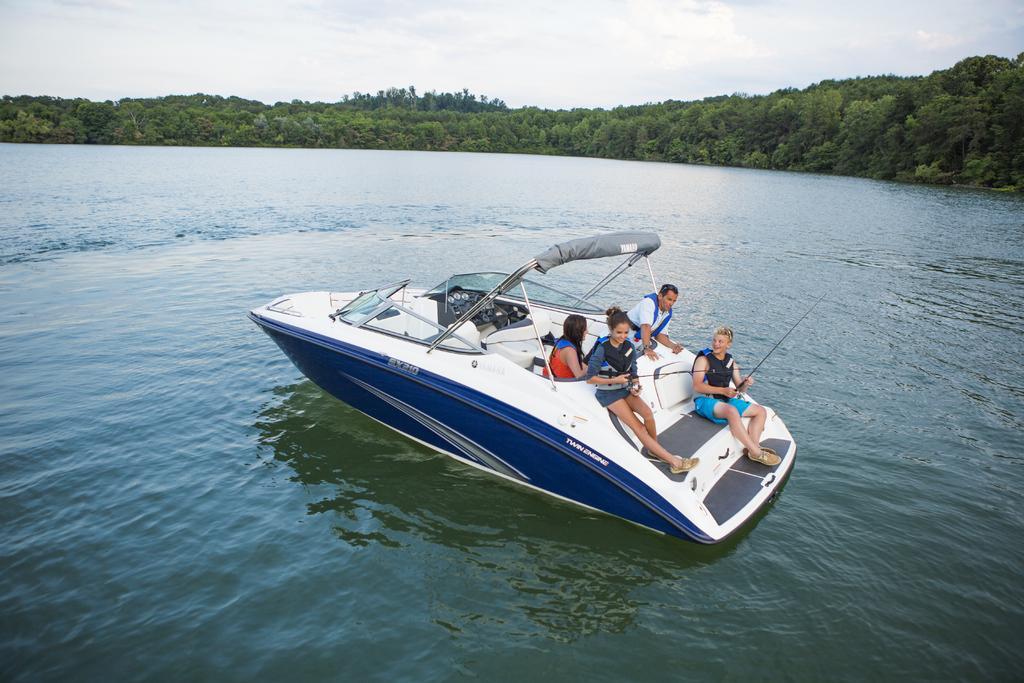Can you describe this image briefly? In the foreground of this picture, there is a boat and four persons on it. In the background, we can see water, trees, and the cloud. 